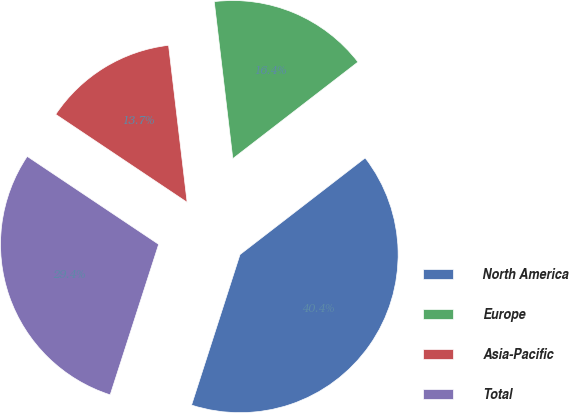Convert chart to OTSL. <chart><loc_0><loc_0><loc_500><loc_500><pie_chart><fcel>North America<fcel>Europe<fcel>Asia-Pacific<fcel>Total<nl><fcel>40.42%<fcel>16.41%<fcel>13.74%<fcel>29.43%<nl></chart> 